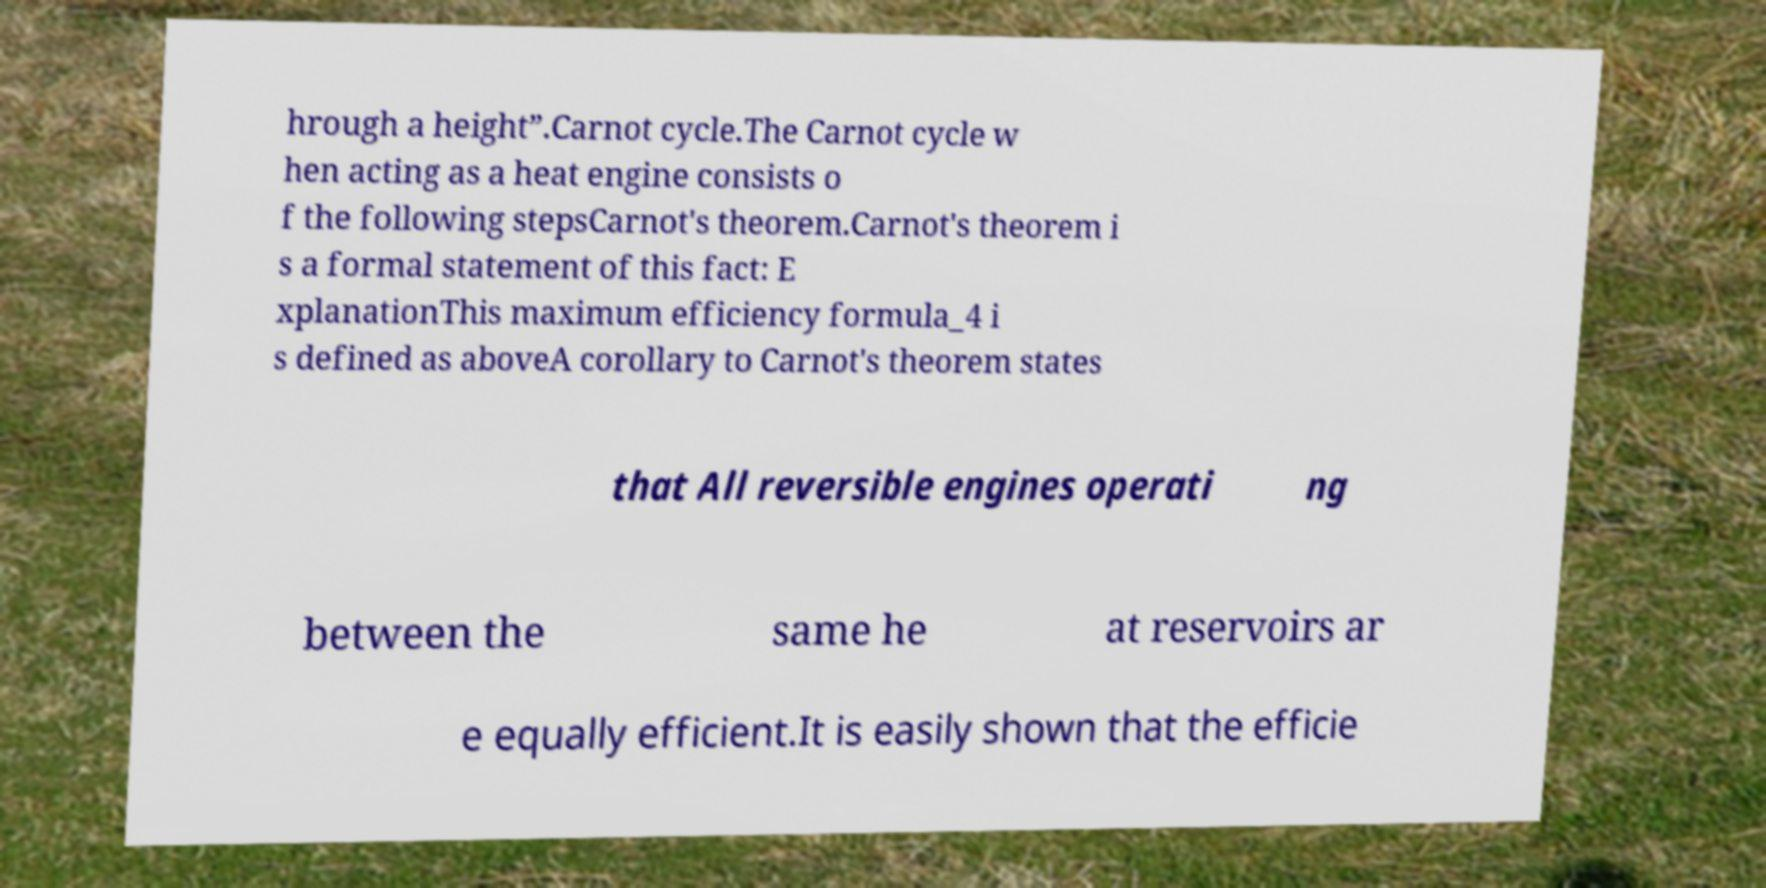I need the written content from this picture converted into text. Can you do that? hrough a height”.Carnot cycle.The Carnot cycle w hen acting as a heat engine consists o f the following stepsCarnot's theorem.Carnot's theorem i s a formal statement of this fact: E xplanationThis maximum efficiency formula_4 i s defined as aboveA corollary to Carnot's theorem states that All reversible engines operati ng between the same he at reservoirs ar e equally efficient.It is easily shown that the efficie 